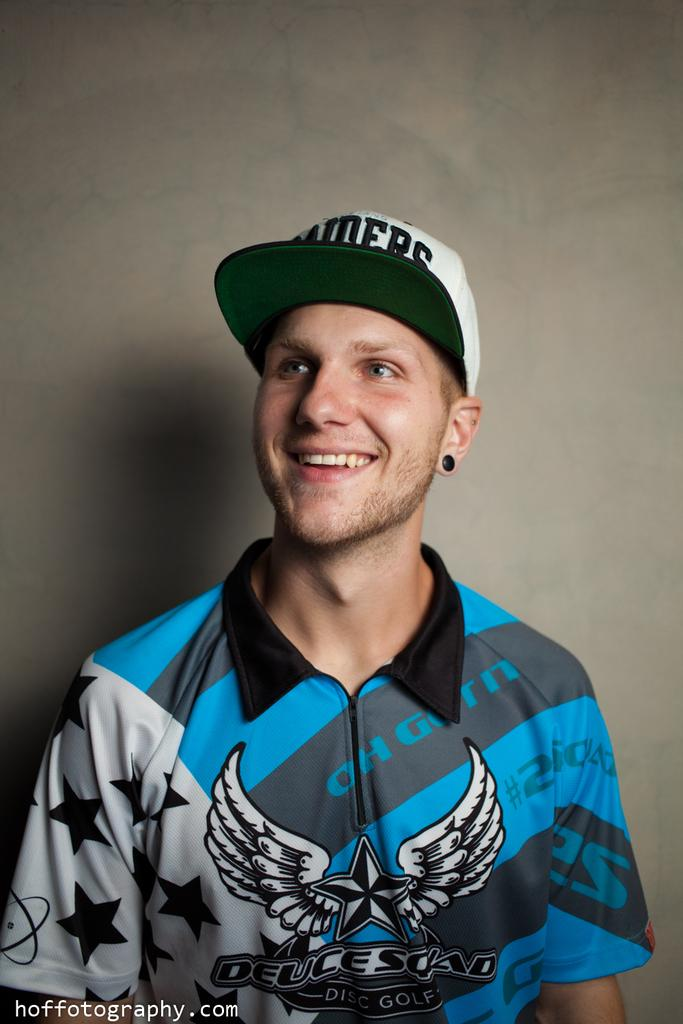Provide a one-sentence caption for the provided image. Young man with a zip up shirt that has deucesquad on the front in black lettering. 